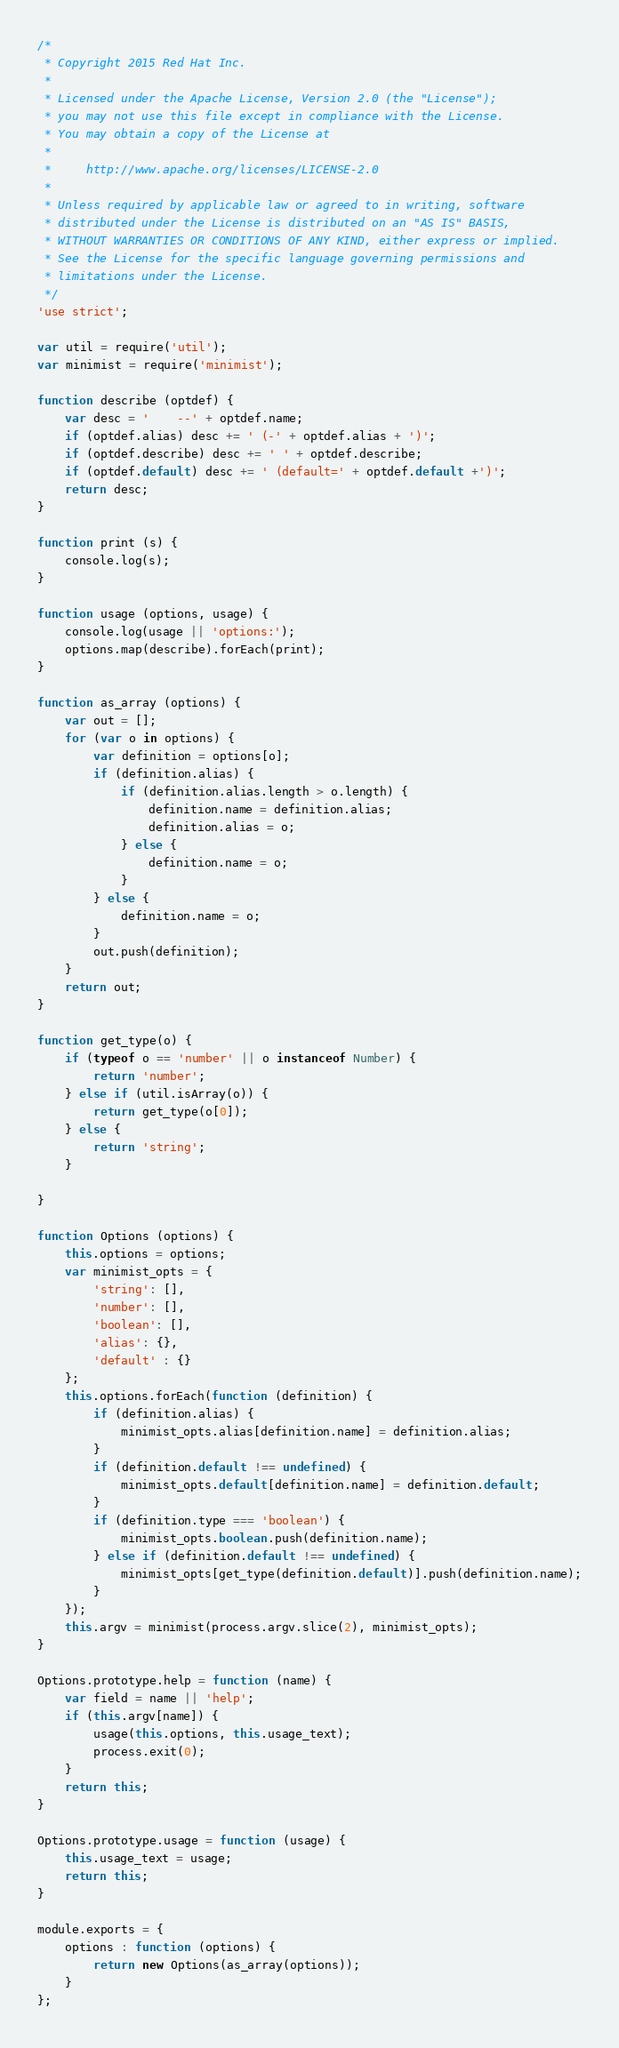Convert code to text. <code><loc_0><loc_0><loc_500><loc_500><_JavaScript_>/*
 * Copyright 2015 Red Hat Inc.
 *
 * Licensed under the Apache License, Version 2.0 (the "License");
 * you may not use this file except in compliance with the License.
 * You may obtain a copy of the License at
 *
 *     http://www.apache.org/licenses/LICENSE-2.0
 *
 * Unless required by applicable law or agreed to in writing, software
 * distributed under the License is distributed on an "AS IS" BASIS,
 * WITHOUT WARRANTIES OR CONDITIONS OF ANY KIND, either express or implied.
 * See the License for the specific language governing permissions and
 * limitations under the License.
 */
'use strict';

var util = require('util');
var minimist = require('minimist');

function describe (optdef) {
    var desc = '    --' + optdef.name;
    if (optdef.alias) desc += ' (-' + optdef.alias + ')';
    if (optdef.describe) desc += ' ' + optdef.describe;
    if (optdef.default) desc += ' (default=' + optdef.default +')';
    return desc;
}

function print (s) {
    console.log(s);
}

function usage (options, usage) {
    console.log(usage || 'options:');
    options.map(describe).forEach(print);
}

function as_array (options) {
    var out = [];
    for (var o in options) {
        var definition = options[o];
        if (definition.alias) {
            if (definition.alias.length > o.length) {
                definition.name = definition.alias;
                definition.alias = o;
            } else {
                definition.name = o;
            }
        } else {
            definition.name = o;
        }
        out.push(definition);
    }
    return out;
}

function get_type(o) {
    if (typeof o == 'number' || o instanceof Number) {
        return 'number';
    } else if (util.isArray(o)) {
        return get_type(o[0]);
    } else {
        return 'string';
    }

}

function Options (options) {
    this.options = options;
    var minimist_opts = {
        'string': [],
        'number': [],
        'boolean': [],
        'alias': {},
        'default' : {}
    };
    this.options.forEach(function (definition) {
        if (definition.alias) {
            minimist_opts.alias[definition.name] = definition.alias;
        }
        if (definition.default !== undefined) {
            minimist_opts.default[definition.name] = definition.default;
        }
        if (definition.type === 'boolean') {
            minimist_opts.boolean.push(definition.name);
        } else if (definition.default !== undefined) {
            minimist_opts[get_type(definition.default)].push(definition.name);
        }
    });
    this.argv = minimist(process.argv.slice(2), minimist_opts);
}

Options.prototype.help = function (name) {
    var field = name || 'help';
    if (this.argv[name]) {
        usage(this.options, this.usage_text);
        process.exit(0);
    }
    return this;
}

Options.prototype.usage = function (usage) {
    this.usage_text = usage;
    return this;
}

module.exports = {
    options : function (options) {
        return new Options(as_array(options));
    }
};
</code> 